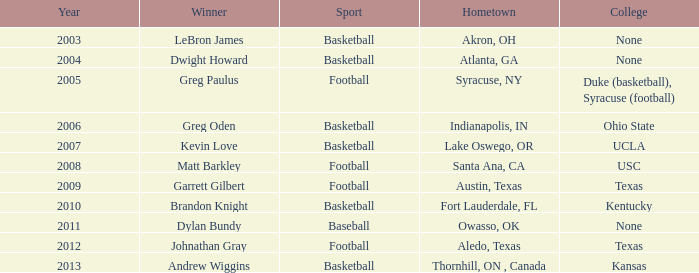Could you help me parse every detail presented in this table? {'header': ['Year', 'Winner', 'Sport', 'Hometown', 'College'], 'rows': [['2003', 'LeBron James', 'Basketball', 'Akron, OH', 'None'], ['2004', 'Dwight Howard', 'Basketball', 'Atlanta, GA', 'None'], ['2005', 'Greg Paulus', 'Football', 'Syracuse, NY', 'Duke (basketball), Syracuse (football)'], ['2006', 'Greg Oden', 'Basketball', 'Indianapolis, IN', 'Ohio State'], ['2007', 'Kevin Love', 'Basketball', 'Lake Oswego, OR', 'UCLA'], ['2008', 'Matt Barkley', 'Football', 'Santa Ana, CA', 'USC'], ['2009', 'Garrett Gilbert', 'Football', 'Austin, Texas', 'Texas'], ['2010', 'Brandon Knight', 'Basketball', 'Fort Lauderdale, FL', 'Kentucky'], ['2011', 'Dylan Bundy', 'Baseball', 'Owasso, OK', 'None'], ['2012', 'Johnathan Gray', 'Football', 'Aledo, Texas', 'Texas'], ['2013', 'Andrew Wiggins', 'Basketball', 'Thornhill, ON , Canada', 'Kansas']]} What is Winner, when College is "Kentucky"? Brandon Knight. 